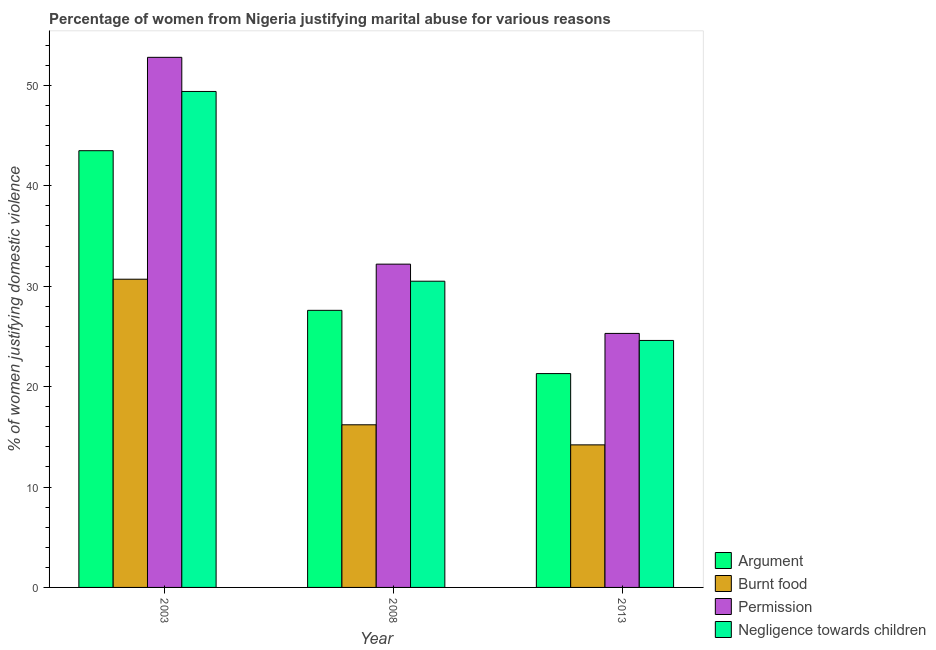Are the number of bars per tick equal to the number of legend labels?
Provide a succinct answer. Yes. How many bars are there on the 2nd tick from the right?
Your answer should be very brief. 4. What is the label of the 2nd group of bars from the left?
Provide a short and direct response. 2008. In how many cases, is the number of bars for a given year not equal to the number of legend labels?
Provide a short and direct response. 0. Across all years, what is the maximum percentage of women justifying abuse in the case of an argument?
Make the answer very short. 43.5. In which year was the percentage of women justifying abuse for showing negligence towards children maximum?
Provide a short and direct response. 2003. In which year was the percentage of women justifying abuse in the case of an argument minimum?
Your answer should be compact. 2013. What is the total percentage of women justifying abuse for burning food in the graph?
Your answer should be very brief. 61.1. What is the difference between the percentage of women justifying abuse for burning food in 2013 and the percentage of women justifying abuse for showing negligence towards children in 2003?
Give a very brief answer. -16.5. What is the average percentage of women justifying abuse for showing negligence towards children per year?
Give a very brief answer. 34.83. In the year 2008, what is the difference between the percentage of women justifying abuse in the case of an argument and percentage of women justifying abuse for going without permission?
Offer a very short reply. 0. What is the ratio of the percentage of women justifying abuse in the case of an argument in 2003 to that in 2008?
Ensure brevity in your answer.  1.58. Is the percentage of women justifying abuse for burning food in 2003 less than that in 2008?
Offer a very short reply. No. Is the difference between the percentage of women justifying abuse for burning food in 2008 and 2013 greater than the difference between the percentage of women justifying abuse in the case of an argument in 2008 and 2013?
Provide a short and direct response. No. What is the difference between the highest and the lowest percentage of women justifying abuse for showing negligence towards children?
Give a very brief answer. 24.8. Is the sum of the percentage of women justifying abuse for showing negligence towards children in 2003 and 2013 greater than the maximum percentage of women justifying abuse for going without permission across all years?
Provide a succinct answer. Yes. What does the 3rd bar from the left in 2013 represents?
Provide a succinct answer. Permission. What does the 2nd bar from the right in 2008 represents?
Your response must be concise. Permission. How many bars are there?
Provide a short and direct response. 12. Are all the bars in the graph horizontal?
Offer a very short reply. No. What is the difference between two consecutive major ticks on the Y-axis?
Give a very brief answer. 10. Does the graph contain any zero values?
Offer a very short reply. No. Does the graph contain grids?
Your answer should be very brief. No. How many legend labels are there?
Give a very brief answer. 4. What is the title of the graph?
Keep it short and to the point. Percentage of women from Nigeria justifying marital abuse for various reasons. What is the label or title of the X-axis?
Offer a very short reply. Year. What is the label or title of the Y-axis?
Make the answer very short. % of women justifying domestic violence. What is the % of women justifying domestic violence of Argument in 2003?
Provide a succinct answer. 43.5. What is the % of women justifying domestic violence in Burnt food in 2003?
Keep it short and to the point. 30.7. What is the % of women justifying domestic violence in Permission in 2003?
Your answer should be compact. 52.8. What is the % of women justifying domestic violence in Negligence towards children in 2003?
Your answer should be compact. 49.4. What is the % of women justifying domestic violence in Argument in 2008?
Provide a short and direct response. 27.6. What is the % of women justifying domestic violence in Burnt food in 2008?
Provide a succinct answer. 16.2. What is the % of women justifying domestic violence of Permission in 2008?
Your answer should be compact. 32.2. What is the % of women justifying domestic violence of Negligence towards children in 2008?
Keep it short and to the point. 30.5. What is the % of women justifying domestic violence in Argument in 2013?
Offer a very short reply. 21.3. What is the % of women justifying domestic violence in Permission in 2013?
Make the answer very short. 25.3. What is the % of women justifying domestic violence of Negligence towards children in 2013?
Ensure brevity in your answer.  24.6. Across all years, what is the maximum % of women justifying domestic violence of Argument?
Give a very brief answer. 43.5. Across all years, what is the maximum % of women justifying domestic violence of Burnt food?
Provide a short and direct response. 30.7. Across all years, what is the maximum % of women justifying domestic violence in Permission?
Your response must be concise. 52.8. Across all years, what is the maximum % of women justifying domestic violence in Negligence towards children?
Your answer should be very brief. 49.4. Across all years, what is the minimum % of women justifying domestic violence in Argument?
Keep it short and to the point. 21.3. Across all years, what is the minimum % of women justifying domestic violence in Burnt food?
Your answer should be compact. 14.2. Across all years, what is the minimum % of women justifying domestic violence of Permission?
Offer a terse response. 25.3. Across all years, what is the minimum % of women justifying domestic violence of Negligence towards children?
Your answer should be compact. 24.6. What is the total % of women justifying domestic violence in Argument in the graph?
Your response must be concise. 92.4. What is the total % of women justifying domestic violence in Burnt food in the graph?
Your response must be concise. 61.1. What is the total % of women justifying domestic violence in Permission in the graph?
Ensure brevity in your answer.  110.3. What is the total % of women justifying domestic violence in Negligence towards children in the graph?
Give a very brief answer. 104.5. What is the difference between the % of women justifying domestic violence in Argument in 2003 and that in 2008?
Your answer should be compact. 15.9. What is the difference between the % of women justifying domestic violence of Burnt food in 2003 and that in 2008?
Ensure brevity in your answer.  14.5. What is the difference between the % of women justifying domestic violence of Permission in 2003 and that in 2008?
Your answer should be very brief. 20.6. What is the difference between the % of women justifying domestic violence in Negligence towards children in 2003 and that in 2008?
Give a very brief answer. 18.9. What is the difference between the % of women justifying domestic violence of Permission in 2003 and that in 2013?
Provide a short and direct response. 27.5. What is the difference between the % of women justifying domestic violence in Negligence towards children in 2003 and that in 2013?
Give a very brief answer. 24.8. What is the difference between the % of women justifying domestic violence in Negligence towards children in 2008 and that in 2013?
Provide a short and direct response. 5.9. What is the difference between the % of women justifying domestic violence of Argument in 2003 and the % of women justifying domestic violence of Burnt food in 2008?
Make the answer very short. 27.3. What is the difference between the % of women justifying domestic violence of Argument in 2003 and the % of women justifying domestic violence of Negligence towards children in 2008?
Keep it short and to the point. 13. What is the difference between the % of women justifying domestic violence in Burnt food in 2003 and the % of women justifying domestic violence in Permission in 2008?
Provide a short and direct response. -1.5. What is the difference between the % of women justifying domestic violence of Burnt food in 2003 and the % of women justifying domestic violence of Negligence towards children in 2008?
Keep it short and to the point. 0.2. What is the difference between the % of women justifying domestic violence in Permission in 2003 and the % of women justifying domestic violence in Negligence towards children in 2008?
Give a very brief answer. 22.3. What is the difference between the % of women justifying domestic violence of Argument in 2003 and the % of women justifying domestic violence of Burnt food in 2013?
Ensure brevity in your answer.  29.3. What is the difference between the % of women justifying domestic violence of Argument in 2003 and the % of women justifying domestic violence of Permission in 2013?
Your answer should be very brief. 18.2. What is the difference between the % of women justifying domestic violence of Argument in 2003 and the % of women justifying domestic violence of Negligence towards children in 2013?
Provide a succinct answer. 18.9. What is the difference between the % of women justifying domestic violence of Permission in 2003 and the % of women justifying domestic violence of Negligence towards children in 2013?
Your response must be concise. 28.2. What is the difference between the % of women justifying domestic violence of Argument in 2008 and the % of women justifying domestic violence of Burnt food in 2013?
Ensure brevity in your answer.  13.4. What is the difference between the % of women justifying domestic violence in Argument in 2008 and the % of women justifying domestic violence in Negligence towards children in 2013?
Ensure brevity in your answer.  3. What is the difference between the % of women justifying domestic violence in Burnt food in 2008 and the % of women justifying domestic violence in Permission in 2013?
Your answer should be very brief. -9.1. What is the difference between the % of women justifying domestic violence in Permission in 2008 and the % of women justifying domestic violence in Negligence towards children in 2013?
Keep it short and to the point. 7.6. What is the average % of women justifying domestic violence of Argument per year?
Make the answer very short. 30.8. What is the average % of women justifying domestic violence of Burnt food per year?
Ensure brevity in your answer.  20.37. What is the average % of women justifying domestic violence in Permission per year?
Your response must be concise. 36.77. What is the average % of women justifying domestic violence in Negligence towards children per year?
Give a very brief answer. 34.83. In the year 2003, what is the difference between the % of women justifying domestic violence in Argument and % of women justifying domestic violence in Negligence towards children?
Give a very brief answer. -5.9. In the year 2003, what is the difference between the % of women justifying domestic violence of Burnt food and % of women justifying domestic violence of Permission?
Offer a terse response. -22.1. In the year 2003, what is the difference between the % of women justifying domestic violence in Burnt food and % of women justifying domestic violence in Negligence towards children?
Provide a short and direct response. -18.7. In the year 2003, what is the difference between the % of women justifying domestic violence in Permission and % of women justifying domestic violence in Negligence towards children?
Offer a terse response. 3.4. In the year 2008, what is the difference between the % of women justifying domestic violence of Argument and % of women justifying domestic violence of Burnt food?
Provide a succinct answer. 11.4. In the year 2008, what is the difference between the % of women justifying domestic violence in Burnt food and % of women justifying domestic violence in Permission?
Your answer should be very brief. -16. In the year 2008, what is the difference between the % of women justifying domestic violence in Burnt food and % of women justifying domestic violence in Negligence towards children?
Offer a terse response. -14.3. In the year 2008, what is the difference between the % of women justifying domestic violence of Permission and % of women justifying domestic violence of Negligence towards children?
Ensure brevity in your answer.  1.7. In the year 2013, what is the difference between the % of women justifying domestic violence in Argument and % of women justifying domestic violence in Permission?
Provide a succinct answer. -4. In the year 2013, what is the difference between the % of women justifying domestic violence in Argument and % of women justifying domestic violence in Negligence towards children?
Give a very brief answer. -3.3. In the year 2013, what is the difference between the % of women justifying domestic violence of Burnt food and % of women justifying domestic violence of Negligence towards children?
Provide a short and direct response. -10.4. In the year 2013, what is the difference between the % of women justifying domestic violence of Permission and % of women justifying domestic violence of Negligence towards children?
Make the answer very short. 0.7. What is the ratio of the % of women justifying domestic violence of Argument in 2003 to that in 2008?
Provide a succinct answer. 1.58. What is the ratio of the % of women justifying domestic violence in Burnt food in 2003 to that in 2008?
Provide a short and direct response. 1.9. What is the ratio of the % of women justifying domestic violence in Permission in 2003 to that in 2008?
Your answer should be compact. 1.64. What is the ratio of the % of women justifying domestic violence in Negligence towards children in 2003 to that in 2008?
Your response must be concise. 1.62. What is the ratio of the % of women justifying domestic violence of Argument in 2003 to that in 2013?
Ensure brevity in your answer.  2.04. What is the ratio of the % of women justifying domestic violence in Burnt food in 2003 to that in 2013?
Keep it short and to the point. 2.16. What is the ratio of the % of women justifying domestic violence of Permission in 2003 to that in 2013?
Provide a succinct answer. 2.09. What is the ratio of the % of women justifying domestic violence in Negligence towards children in 2003 to that in 2013?
Give a very brief answer. 2.01. What is the ratio of the % of women justifying domestic violence in Argument in 2008 to that in 2013?
Keep it short and to the point. 1.3. What is the ratio of the % of women justifying domestic violence in Burnt food in 2008 to that in 2013?
Provide a succinct answer. 1.14. What is the ratio of the % of women justifying domestic violence of Permission in 2008 to that in 2013?
Provide a short and direct response. 1.27. What is the ratio of the % of women justifying domestic violence in Negligence towards children in 2008 to that in 2013?
Your answer should be compact. 1.24. What is the difference between the highest and the second highest % of women justifying domestic violence in Permission?
Give a very brief answer. 20.6. What is the difference between the highest and the second highest % of women justifying domestic violence of Negligence towards children?
Your answer should be very brief. 18.9. What is the difference between the highest and the lowest % of women justifying domestic violence in Permission?
Give a very brief answer. 27.5. What is the difference between the highest and the lowest % of women justifying domestic violence of Negligence towards children?
Keep it short and to the point. 24.8. 